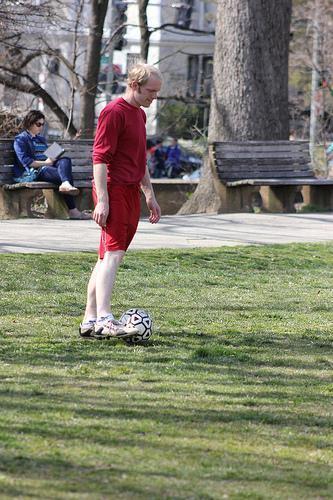How many trees are there?
Give a very brief answer. 3. How many people are there?
Give a very brief answer. 2. 